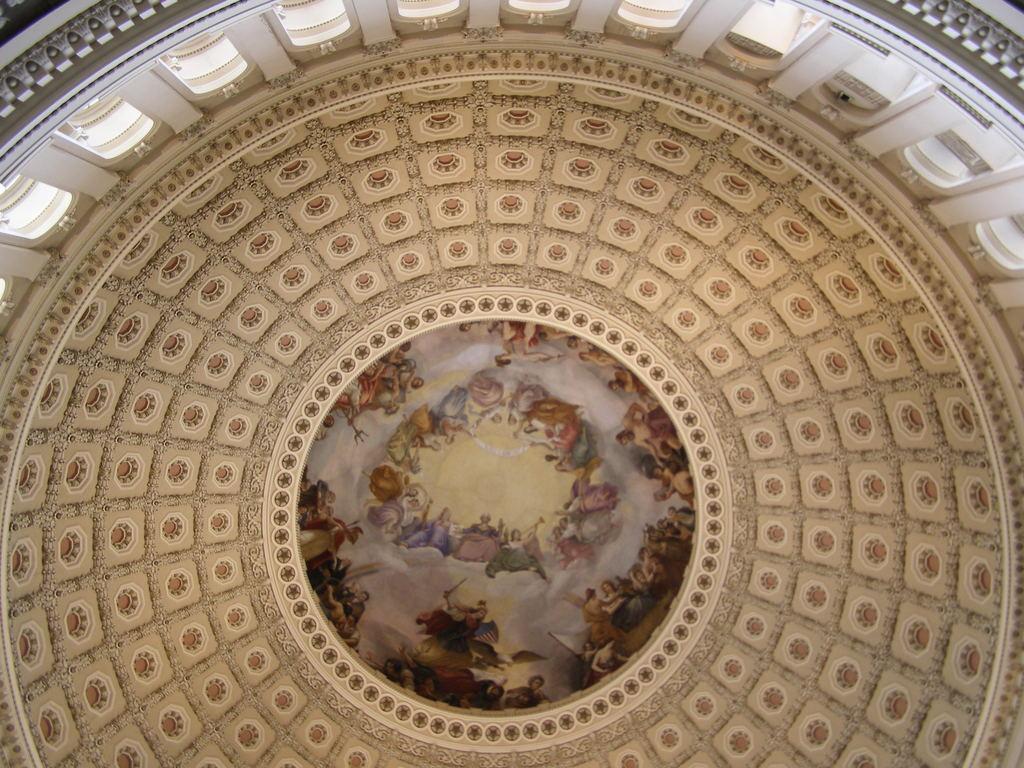How would you summarize this image in a sentence or two? This is interior of a building which has a picture in middle of it. 